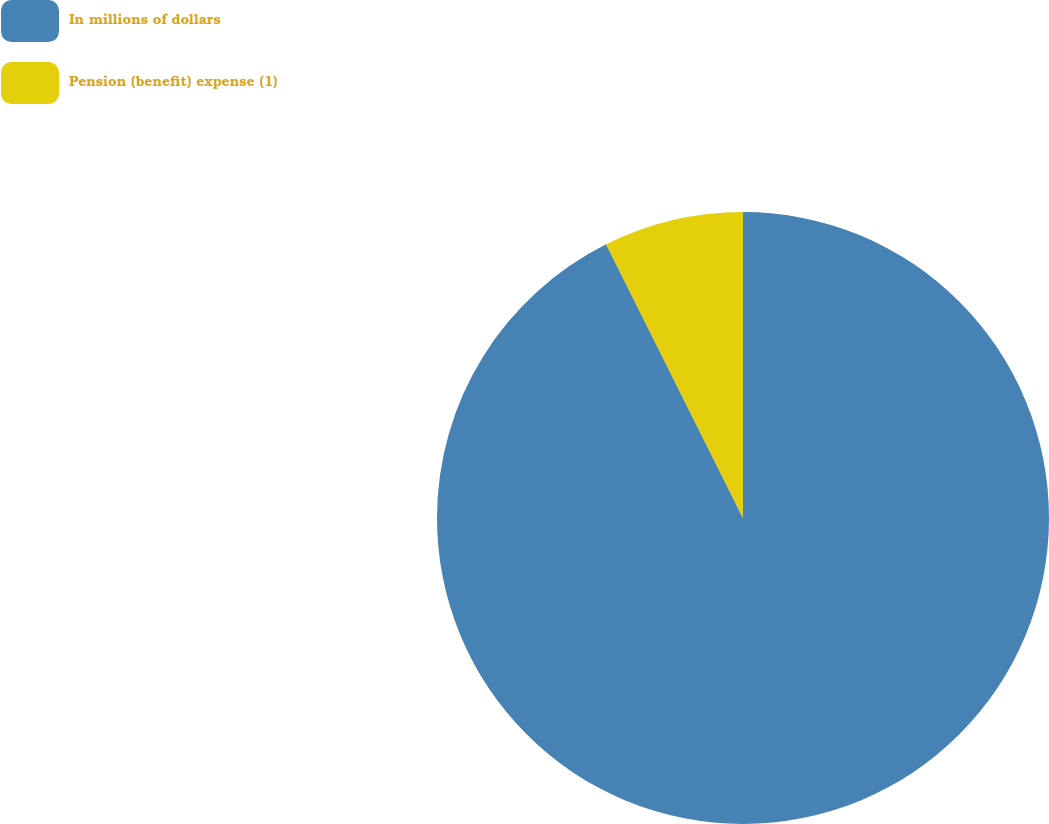Convert chart to OTSL. <chart><loc_0><loc_0><loc_500><loc_500><pie_chart><fcel>In millions of dollars<fcel>Pension (benefit) expense (1)<nl><fcel>92.62%<fcel>7.38%<nl></chart> 